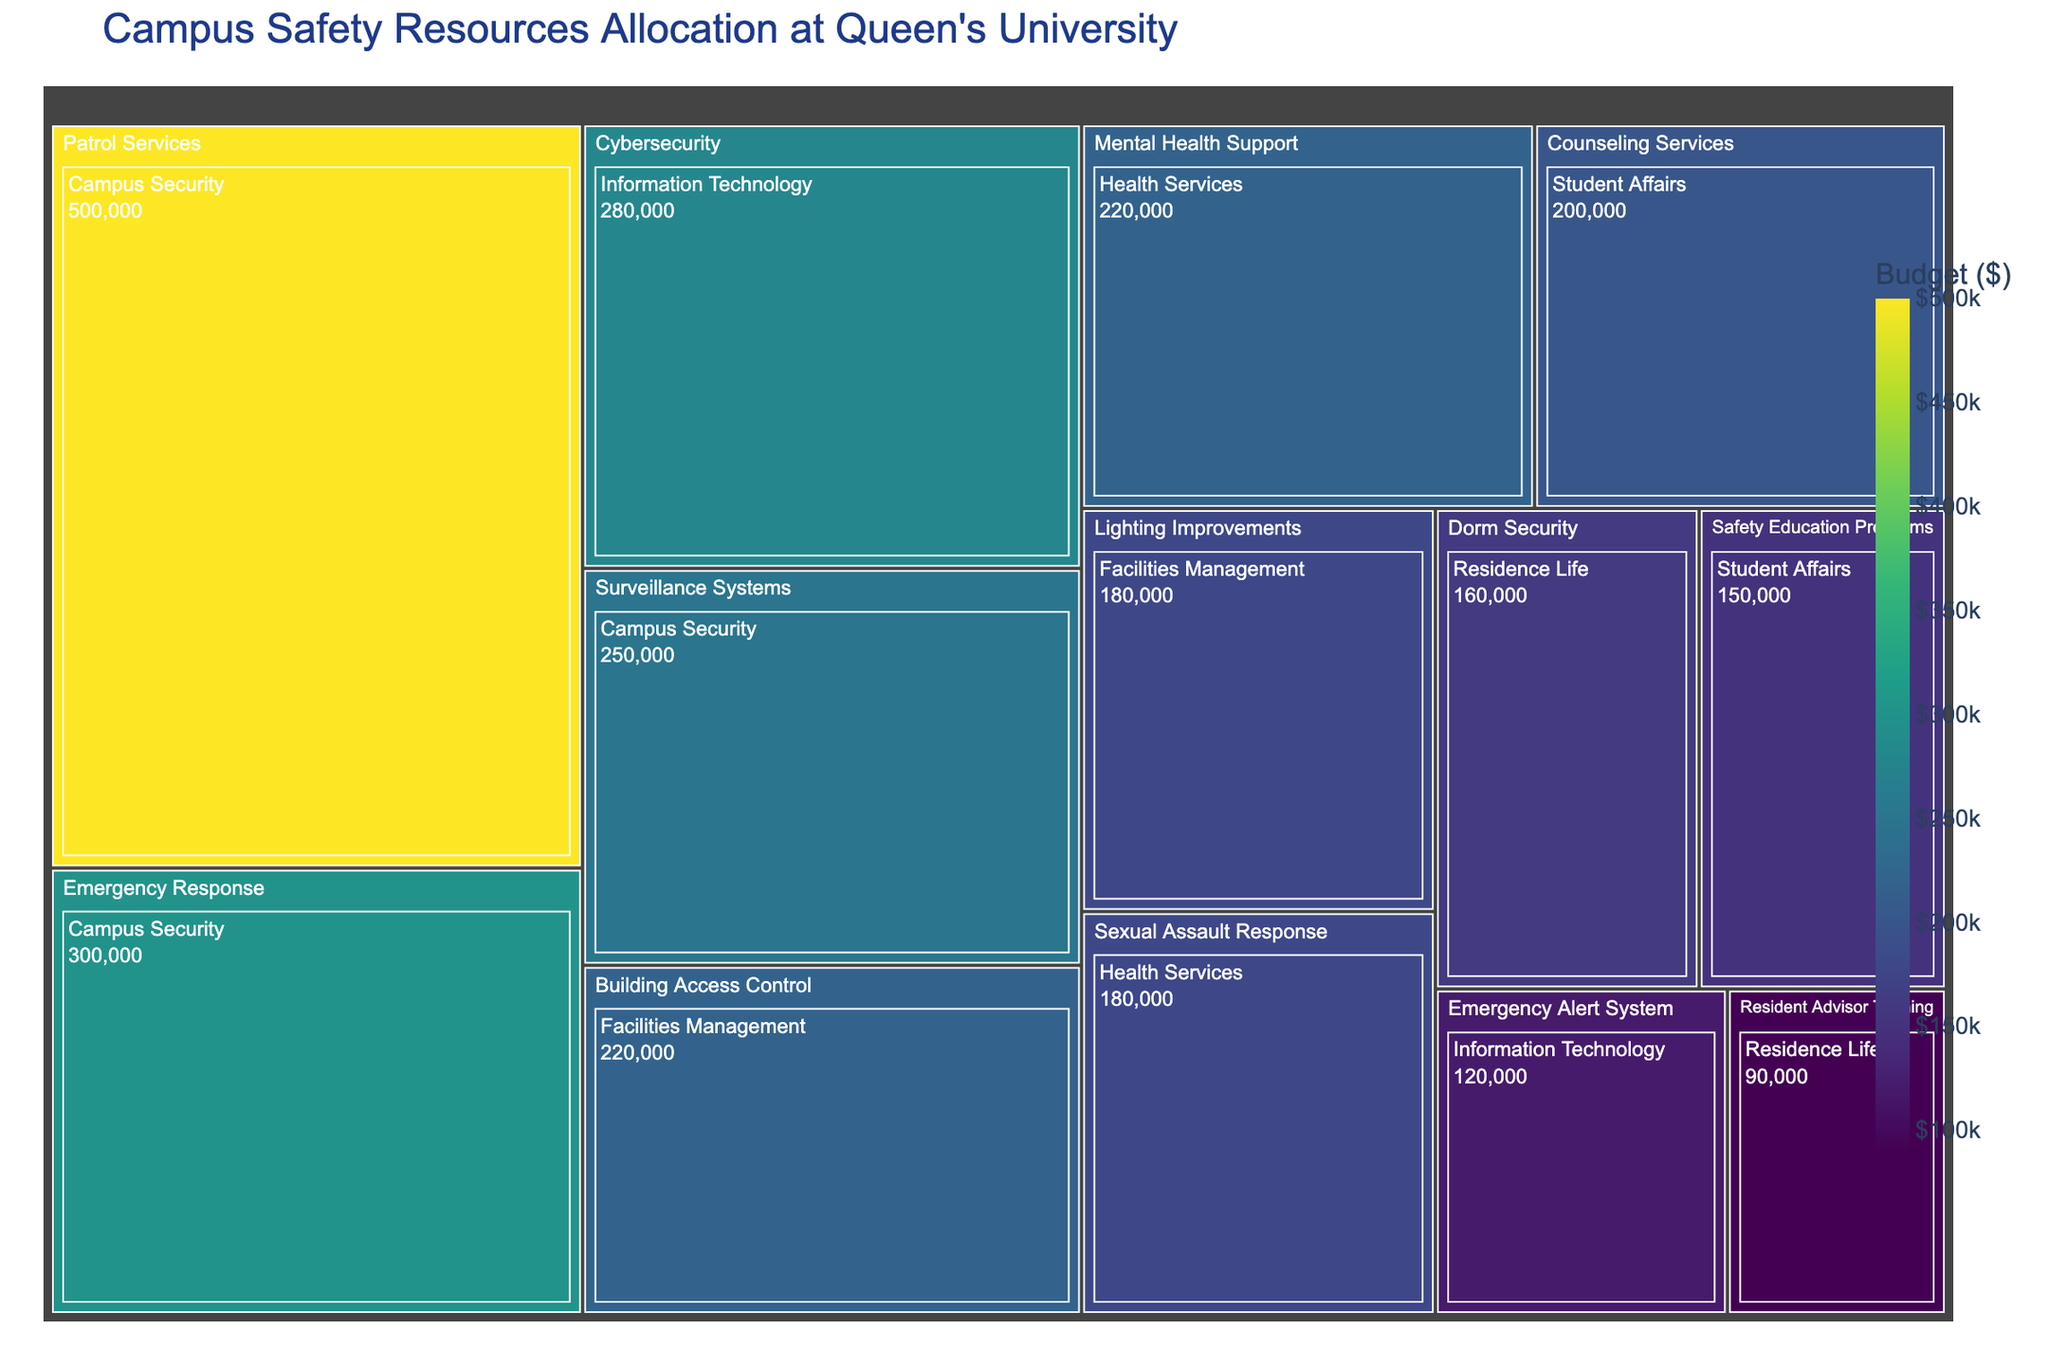What is the title of the Treemap? The title of the Treemap is displayed prominently at the top of the figure. It summarizes the content and purpose of the visualization.
Answer: Campus Safety Resources Allocation at Queen's University Which department has the highest budget allocation within Campus Security? The Treemap color intensity and relative size of sections represent the budget allocation for different categories within each department, highlighting where the highest allocations lie.
Answer: Patrol Services How much total budget is allocated to the department of Information Technology? To find the total budget for Information Technology, add the budget allocations for Cybersecurity and Emergency Alert System as displayed in the categories within the Information Technology section.
Answer: $400,000 Compare the budget for Safety Education Programs in Student Affairs to the budget for Dorm Security in Residence Life. Which one has a higher allocation? By comparing the dimensions of the sections and their labeled budgets, we can see which category has a higher budget within their respective departments.
Answer: Dorm Security What is the sum of budgets allocated to Health Services? To find the total, sum the budgets for Sexual Assault Response and Mental Health Support under the Health Services section.
Answer: $400,000 How is the budget for Building Access Control in Facilities Management compared to Mental Health Support in Health Services? Examine the sizes and values of the specific sections for Building Access Control and Mental Health Support to determine the comparative budget allocations.
Answer: Building Access Control has a lower allocation What share of the total campus safety budget is allocated to Counseling Services in Student Affairs? First, find the total campus safety budget by summing the budgets of all categories. Then, calculate the share by dividing the budget for Counseling Services by the total and multiplying by 100 to get the percentage.
Answer: 5.56% Which category within the Facilities Management department has a higher budget allocation, Lighting Improvements or Building Access Control? Compare the respective categories' sizes and budget labels under the Facilities Management department to see which has a higher budget.
Answer: Building Access Control What is the total budget allocated to Campus Security and Facilities Management combined? Add the total budgets allocated to each category within Campus Security and Facilities Management and sum the results to find the combined total.
Answer: $1,450,000 